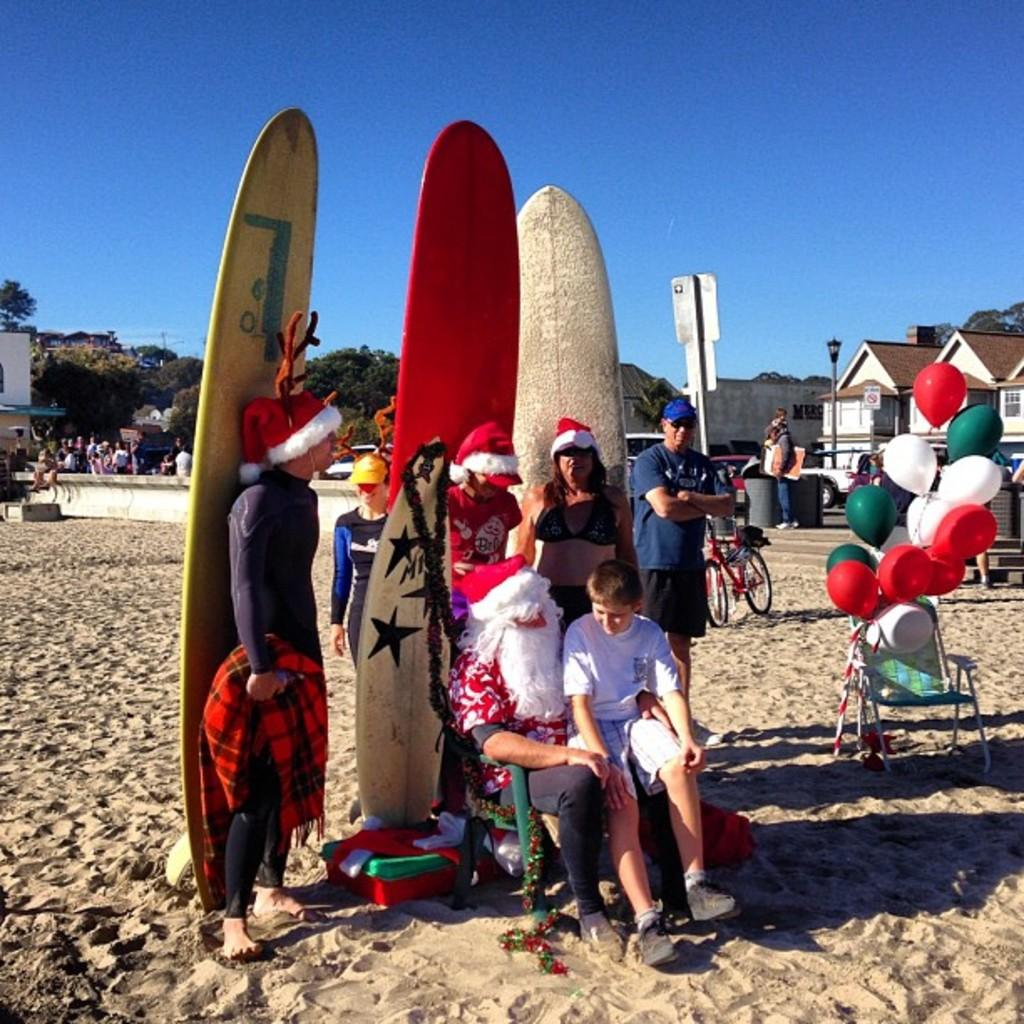What objects can be seen in the image? There are boards, a bicycle, a chair, balloons, signboards, a light pole, a hoarding, drums, and trees visible in the image. Are there any people present in the image? Yes, there are people in the image. What type of structure can be seen in the background? There are buildings visible in the image. What can be seen on the ground in the image? Soil is visible in the image. What is visible in the background of the image? The sky is visible in the background of the image. What type of cake is being served at the event in the image? There is no event or cake present in the image. Can you tell me how many eggs are in the eggnog being consumed by the people in the image? There is no eggnog or eggs present in the image. 